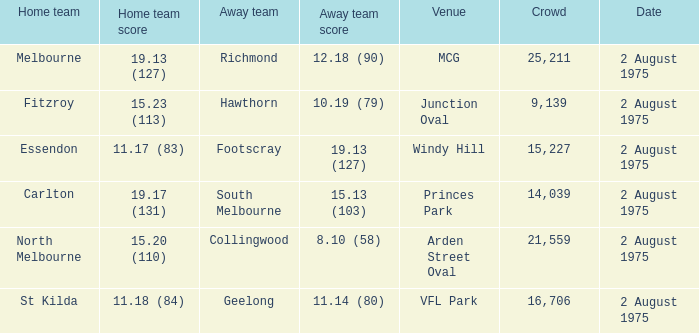How many individuals were present at the vfl park match? 16706.0. 